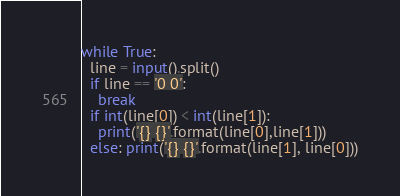Convert code to text. <code><loc_0><loc_0><loc_500><loc_500><_Python_>while True:
  line = input().split()
  if line == '0 0':
    break
  if int(line[0]) < int(line[1]):
    print('{} {}'.format(line[0],line[1]))
  else: print('{} {}'.format(line[1], line[0]))</code> 